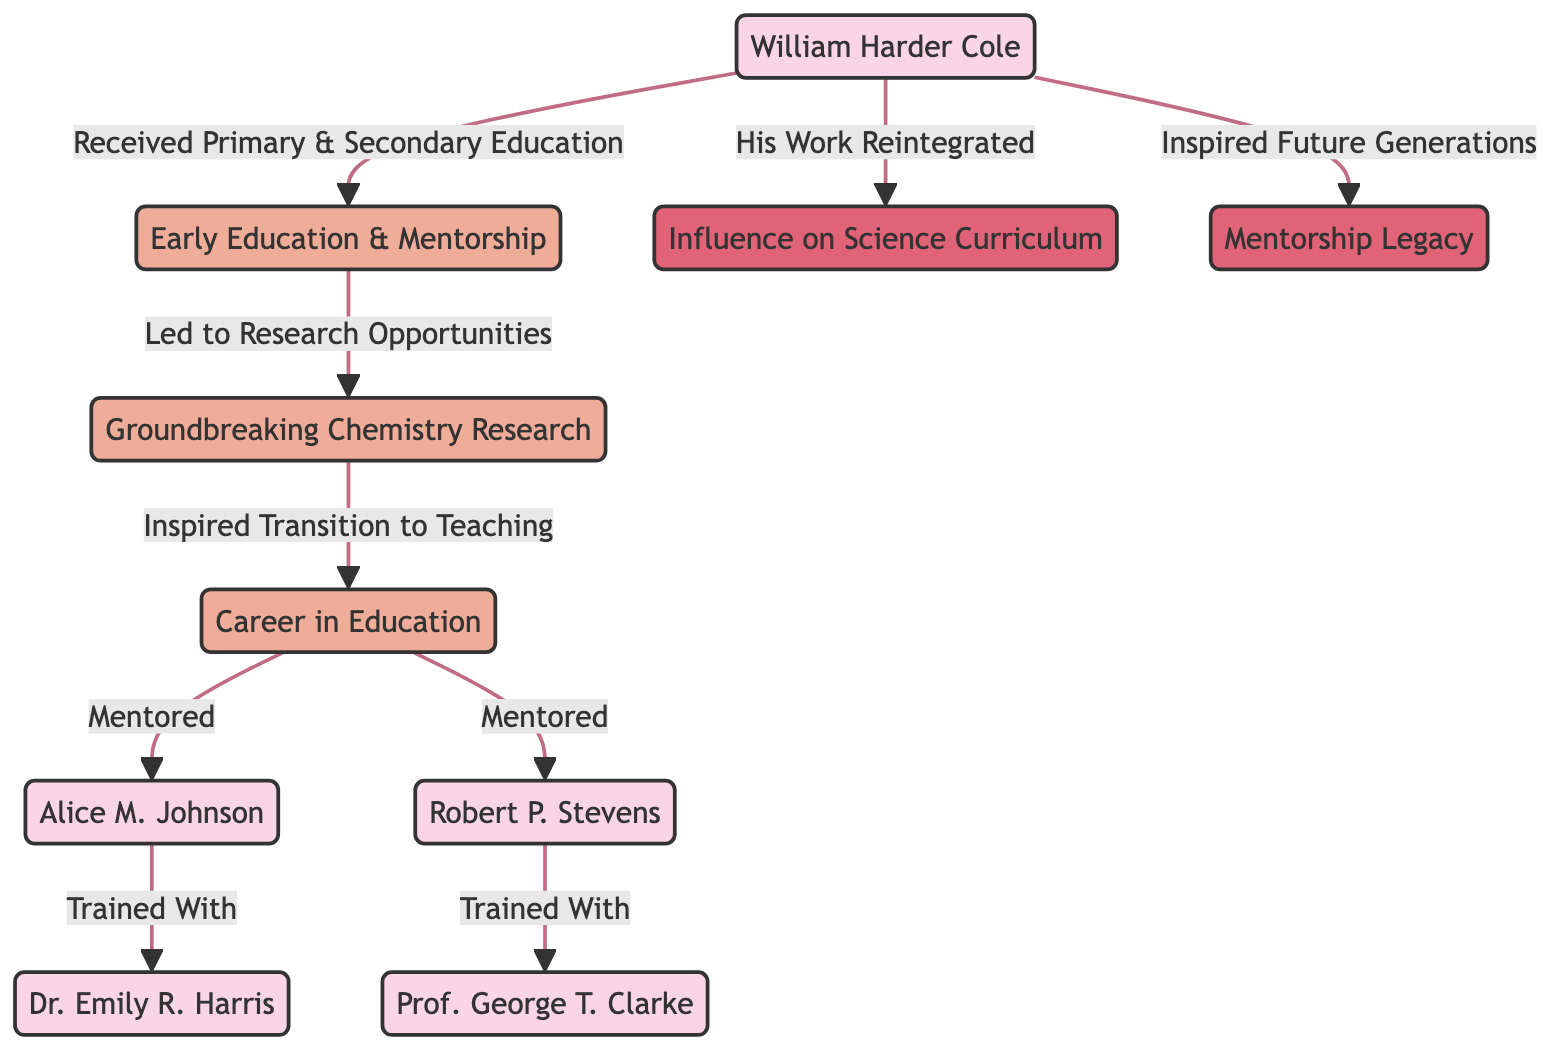What is the central figure of the diagram? The central figure is "William Harder Cole," who plays a pivotal role in the overall narrative of the diagram.
Answer: William Harder Cole How many students are mentored by William Harder Cole? According to the diagram, there are two individuals directly mentored by William Harder Cole, indicated by the arrows leading to the students from his teaching career.
Answer: 2 What event is directly related to William Harder Cole's influence on science curriculum? The influence on science curriculum is described as "His Work Reintegrated," showing a direct connection from William Harder Cole to the impact on curriculum development.
Answer: His Work Reintegrated Who is the first educator trained by Alice M. Johnson? The diagram shows that Alice M. Johnson, one of the students mentored by William Harder Cole, went on to train with Dr. Emily R. Harris.
Answer: Dr. Emily R. Harris What led to the transition from chemistry research to teaching in Cole's career? The transition is indicated by "Inspired Transition to Teaching," which connects the groundbreaking research directly to his teaching career.
Answer: Inspired Transition to Teaching How are the mentorship legacies depicted in the diagram? The mentorship legacies are depicted by the connection labeled "Mentorship Legacy," which emerges from William Harder Cole, indicating his ongoing influence on future generations of scientists and educators.
Answer: Mentorship Legacy What was the primary outcome of William Harder Cole's early education and mentorship? The primary outcome is represented by "Led to Research Opportunities," indicating the significance of early education in shaping his future contributions to science.
Answer: Led to Research Opportunities What role did Robert P. Stevens play in relation to William Harder Cole? Robert P. Stevens is shown as a student who was mentored by William Harder Cole and continues the educational lineage from him.
Answer: Student What is the significance of the node "Groundbreaking Chemistry Research"? This node signifies a key event in William Harder Cole's career that transitioned him from research to education, thus laying the groundwork for his future mentoring efforts.
Answer: Groundbreaking Chemistry Research 